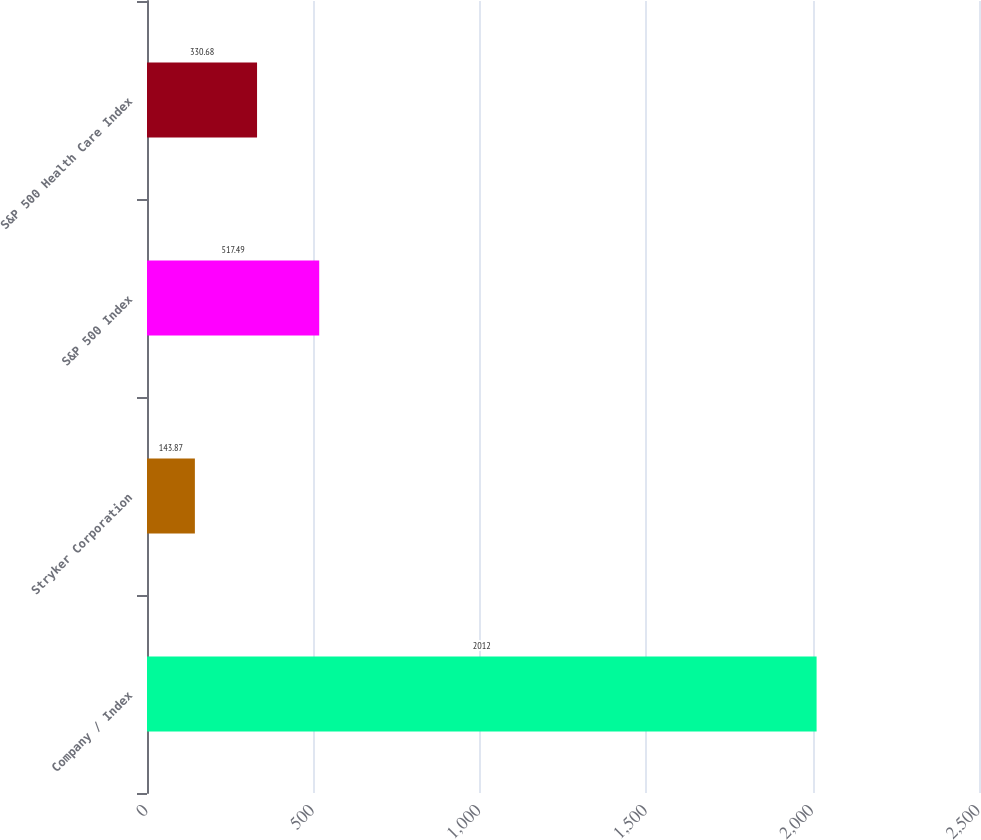<chart> <loc_0><loc_0><loc_500><loc_500><bar_chart><fcel>Company / Index<fcel>Stryker Corporation<fcel>S&P 500 Index<fcel>S&P 500 Health Care Index<nl><fcel>2012<fcel>143.87<fcel>517.49<fcel>330.68<nl></chart> 